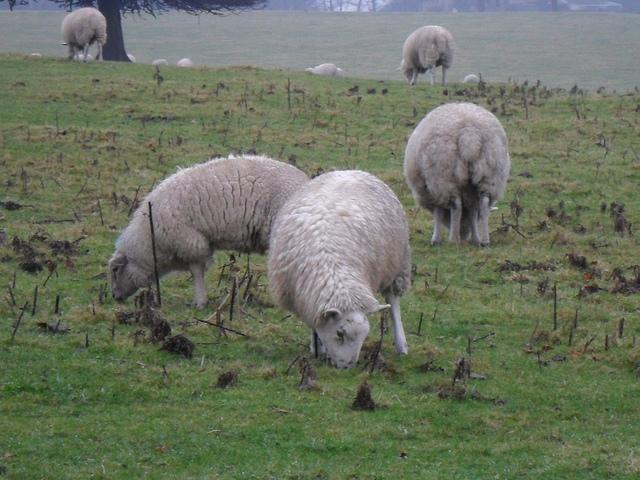How many sheep are there?
Keep it brief. 5. Are the animals carnivores?
Quick response, please. No. How many animals are in the picture?
Short answer required. 5. What color are the sheeps heads?
Write a very short answer. White. How many animals are there?
Write a very short answer. 5. What type of animal is in the photo?
Give a very brief answer. Sheep. 